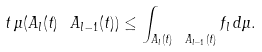Convert formula to latex. <formula><loc_0><loc_0><loc_500><loc_500>t \, \mu ( A _ { l } ( t ) \ A _ { l - 1 } ( t ) ) \leq \int _ { A _ { l } ( t ) \ A _ { l - 1 } ( t ) } f _ { l } \, d \mu .</formula> 